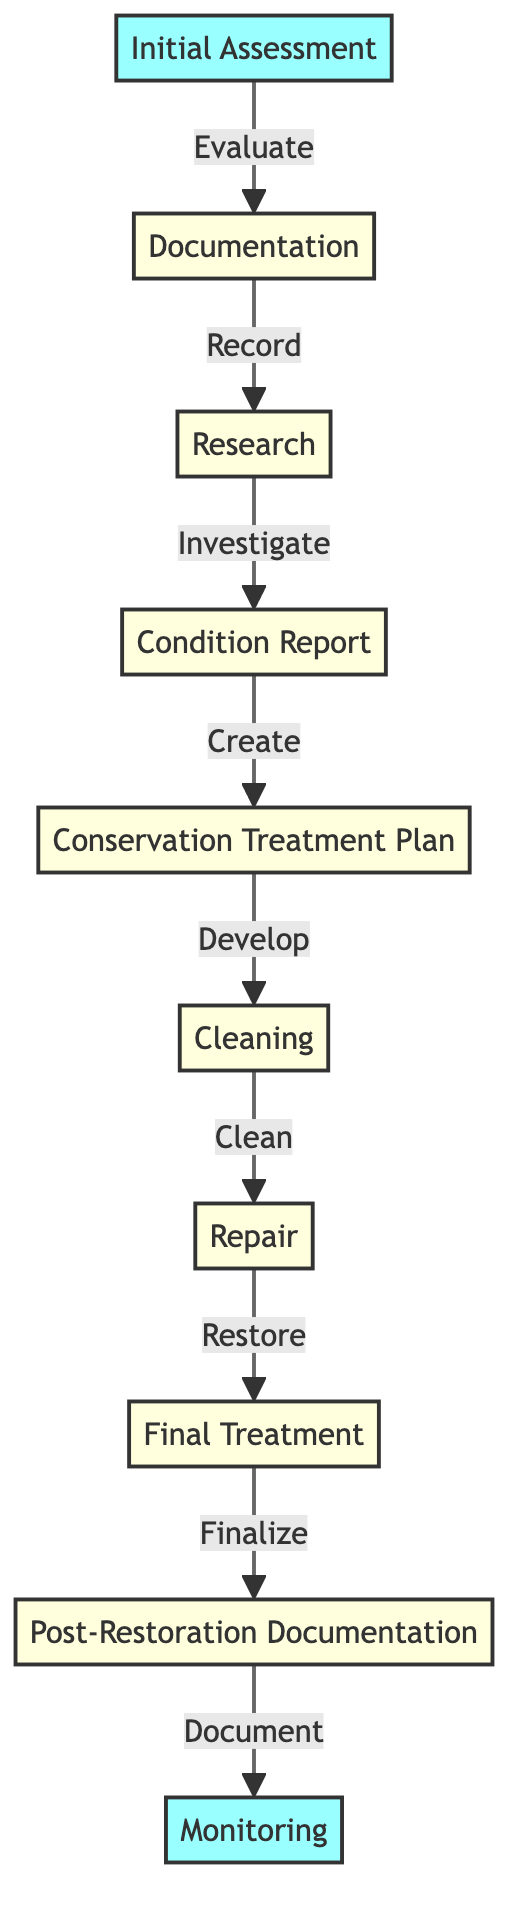What is the first step in the restoration process? The diagram indicates that the first step is "Initial Assessment," which is the starting point of the workflow.
Answer: Initial Assessment How many nodes are present in the diagram? By counting the elements listed in the data, there are 10 unique nodes representing different steps in the restoration process.
Answer: 10 What follows the "Condition Report"? Looking at the directed relationships in the diagram, the step that follows "Condition Report" is "Conservation Treatment Plan."
Answer: Conservation Treatment Plan What is the last step in the workflow? The last node connected in the diagram is "Monitoring," which signifies the final step for ongoing care after restoration.
Answer: Monitoring Which step comes after "Cleaning"? The diagram shows that "Repair" comes immediately after the "Cleaning" step, indicating that repairs are made post-cleaning.
Answer: Repair How many connections are there from "Initial Assessment"? From the diagram, "Initial Assessment" has one outgoing connection leading to "Documentation," indicating it influences only one subsequent process.
Answer: 1 What are the two main phases of the restoration process as shown in the diagram? The diagram can be divided into two main phases: assessment and reporting, followed by treatment and documentation, encapsulating all necessary steps from assessment to monitoring.
Answer: Assessment and Treatment What does "Final Treatment" lead to? The flow indicates that "Final Treatment" leads directly to "Post-Restoration Documentation," completing the treatment phase before documentation occurs.
Answer: Post-Restoration Documentation 